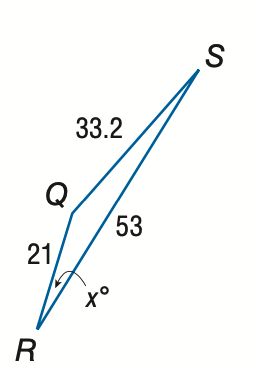Answer the mathemtical geometry problem and directly provide the correct option letter.
Question: Find x. Round the angle measure to the nearest degree.
Choices: A: 12 B: 15 C: 18 D: 21 B 